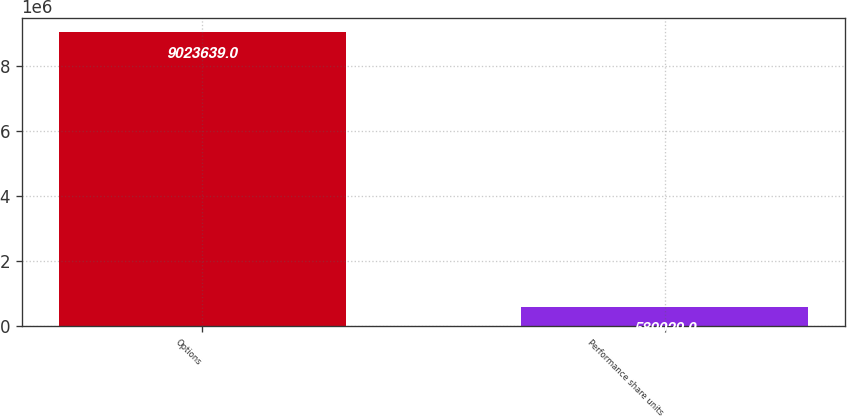Convert chart to OTSL. <chart><loc_0><loc_0><loc_500><loc_500><bar_chart><fcel>Options<fcel>Performance share units<nl><fcel>9.02364e+06<fcel>589029<nl></chart> 